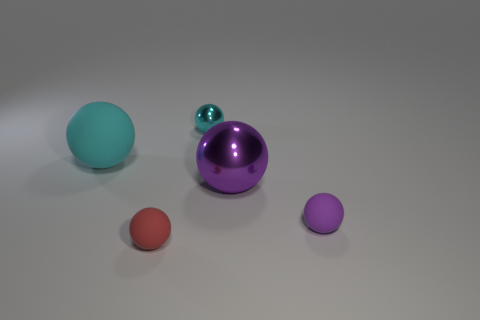Subtract all small cyan balls. How many balls are left? 4 Subtract all blue blocks. How many purple spheres are left? 2 Subtract all cyan spheres. How many spheres are left? 3 Add 2 big cyan objects. How many objects exist? 7 Subtract all green balls. Subtract all brown cylinders. How many balls are left? 5 Subtract 0 yellow balls. How many objects are left? 5 Subtract all large cyan rubber spheres. Subtract all purple metal things. How many objects are left? 3 Add 4 purple things. How many purple things are left? 6 Add 1 large blue matte spheres. How many large blue matte spheres exist? 1 